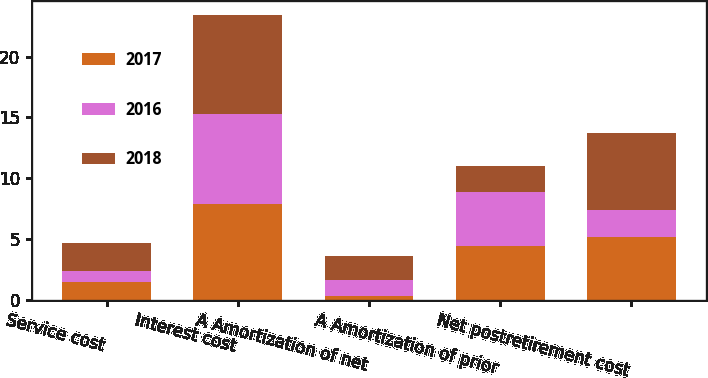Convert chart. <chart><loc_0><loc_0><loc_500><loc_500><stacked_bar_chart><ecel><fcel>Service cost<fcel>Interest cost<fcel>A Amortization of net<fcel>A Amortization of prior<fcel>Net postretirement cost<nl><fcel>2017<fcel>1.5<fcel>7.9<fcel>0.3<fcel>4.4<fcel>5.2<nl><fcel>2016<fcel>0.9<fcel>7.4<fcel>1.3<fcel>4.5<fcel>2.2<nl><fcel>2018<fcel>2.3<fcel>8.1<fcel>2<fcel>2.1<fcel>6.3<nl></chart> 